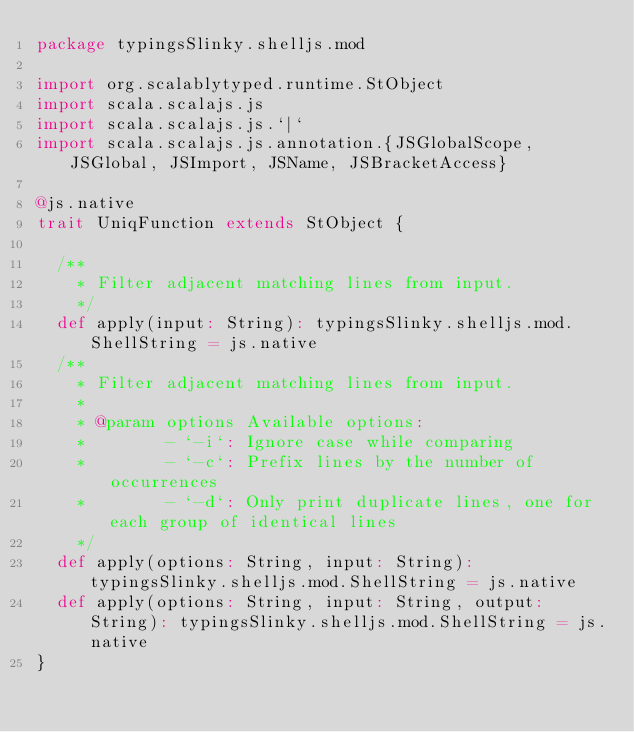<code> <loc_0><loc_0><loc_500><loc_500><_Scala_>package typingsSlinky.shelljs.mod

import org.scalablytyped.runtime.StObject
import scala.scalajs.js
import scala.scalajs.js.`|`
import scala.scalajs.js.annotation.{JSGlobalScope, JSGlobal, JSImport, JSName, JSBracketAccess}

@js.native
trait UniqFunction extends StObject {
  
  /**
    * Filter adjacent matching lines from input.
    */
  def apply(input: String): typingsSlinky.shelljs.mod.ShellString = js.native
  /**
    * Filter adjacent matching lines from input.
    *
    * @param options Available options:
    *        - `-i`: Ignore case while comparing
    *        - `-c`: Prefix lines by the number of occurrences
    *        - `-d`: Only print duplicate lines, one for each group of identical lines
    */
  def apply(options: String, input: String): typingsSlinky.shelljs.mod.ShellString = js.native
  def apply(options: String, input: String, output: String): typingsSlinky.shelljs.mod.ShellString = js.native
}
</code> 